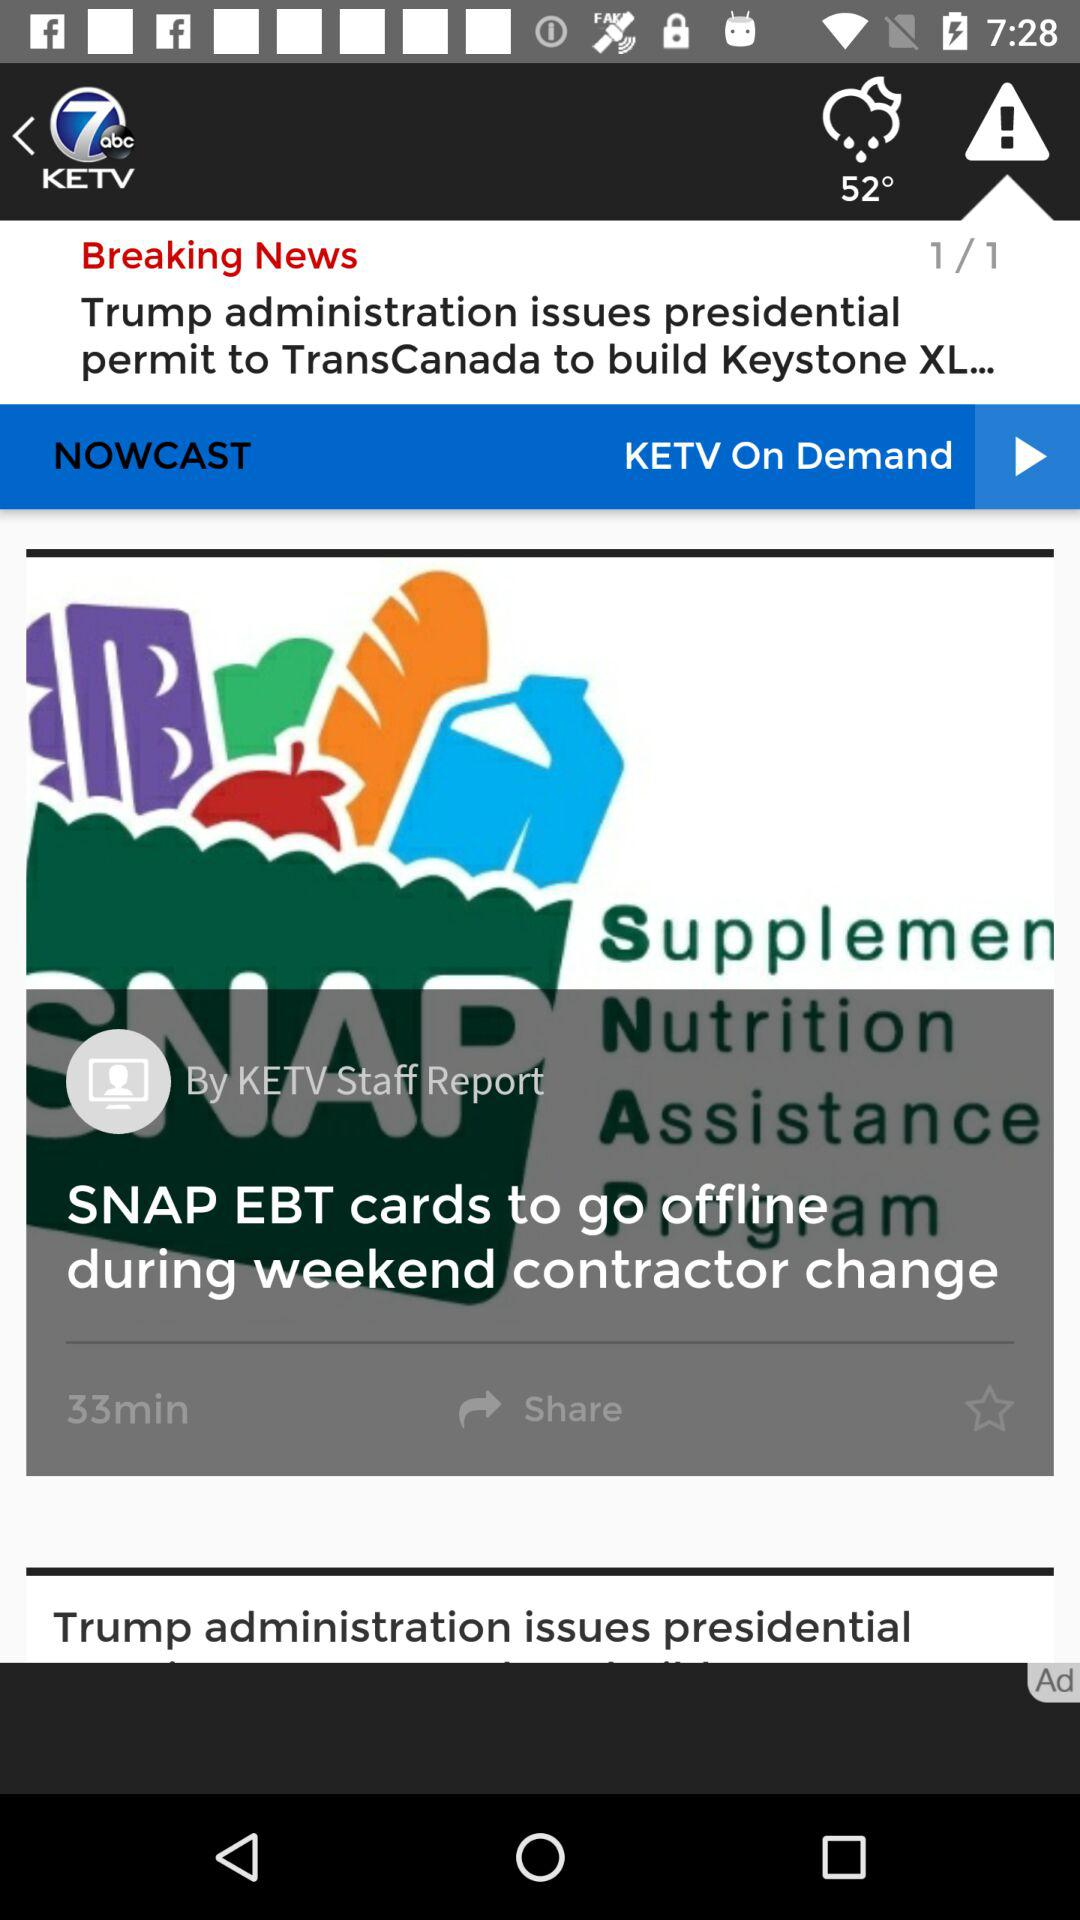What's the temperature? The temperature is 52°. 